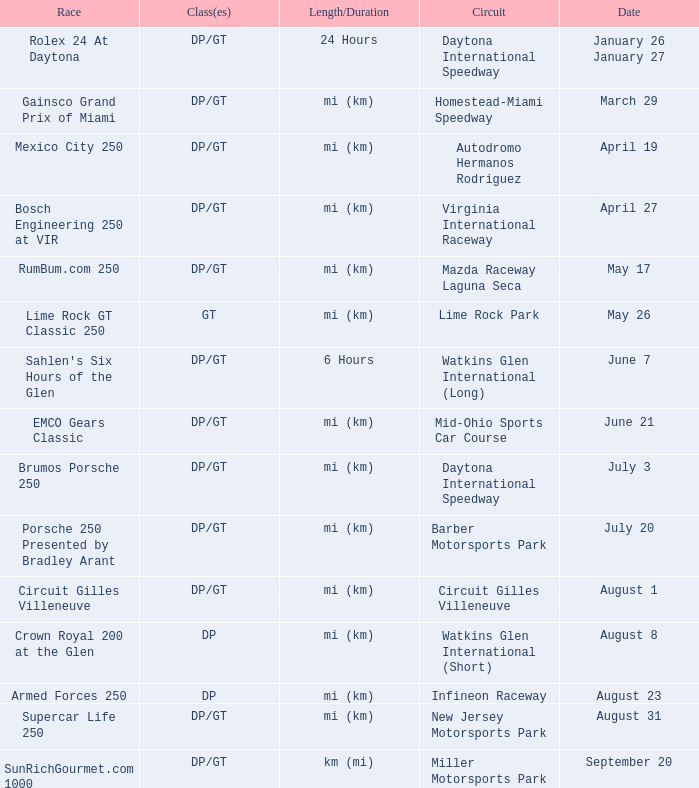I'm looking to parse the entire table for insights. Could you assist me with that? {'header': ['Race', 'Class(es)', 'Length/Duration', 'Circuit', 'Date'], 'rows': [['Rolex 24 At Daytona', 'DP/GT', '24 Hours', 'Daytona International Speedway', 'January 26 January 27'], ['Gainsco Grand Prix of Miami', 'DP/GT', 'mi (km)', 'Homestead-Miami Speedway', 'March 29'], ['Mexico City 250', 'DP/GT', 'mi (km)', 'Autodromo Hermanos Rodriguez', 'April 19'], ['Bosch Engineering 250 at VIR', 'DP/GT', 'mi (km)', 'Virginia International Raceway', 'April 27'], ['RumBum.com 250', 'DP/GT', 'mi (km)', 'Mazda Raceway Laguna Seca', 'May 17'], ['Lime Rock GT Classic 250', 'GT', 'mi (km)', 'Lime Rock Park', 'May 26'], ["Sahlen's Six Hours of the Glen", 'DP/GT', '6 Hours', 'Watkins Glen International (Long)', 'June 7'], ['EMCO Gears Classic', 'DP/GT', 'mi (km)', 'Mid-Ohio Sports Car Course', 'June 21'], ['Brumos Porsche 250', 'DP/GT', 'mi (km)', 'Daytona International Speedway', 'July 3'], ['Porsche 250 Presented by Bradley Arant', 'DP/GT', 'mi (km)', 'Barber Motorsports Park', 'July 20'], ['Circuit Gilles Villeneuve', 'DP/GT', 'mi (km)', 'Circuit Gilles Villeneuve', 'August 1'], ['Crown Royal 200 at the Glen', 'DP', 'mi (km)', 'Watkins Glen International (Short)', 'August 8'], ['Armed Forces 250', 'DP', 'mi (km)', 'Infineon Raceway', 'August 23'], ['Supercar Life 250', 'DP/GT', 'mi (km)', 'New Jersey Motorsports Park', 'August 31'], ['SunRichGourmet.com 1000', 'DP/GT', 'km (mi)', 'Miller Motorsports Park', 'September 20']]} What was the circuit had a race on September 20. Miller Motorsports Park. 